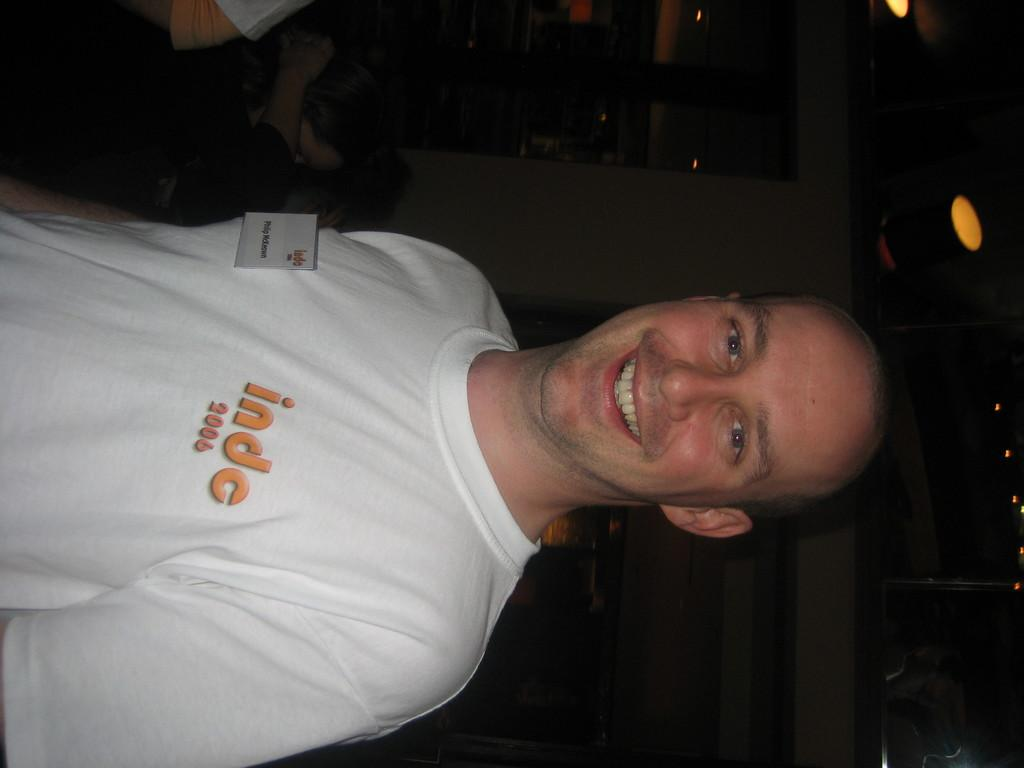How many people are present in the image? There is one person and a few other persons present in the image. Can you describe the people in the image? Unfortunately, the provided facts do not give any specific details about the people in the image. What type of cakes are being served to the earth in the image? There is no reference to cakes, earth, or any serving activity in the image. 